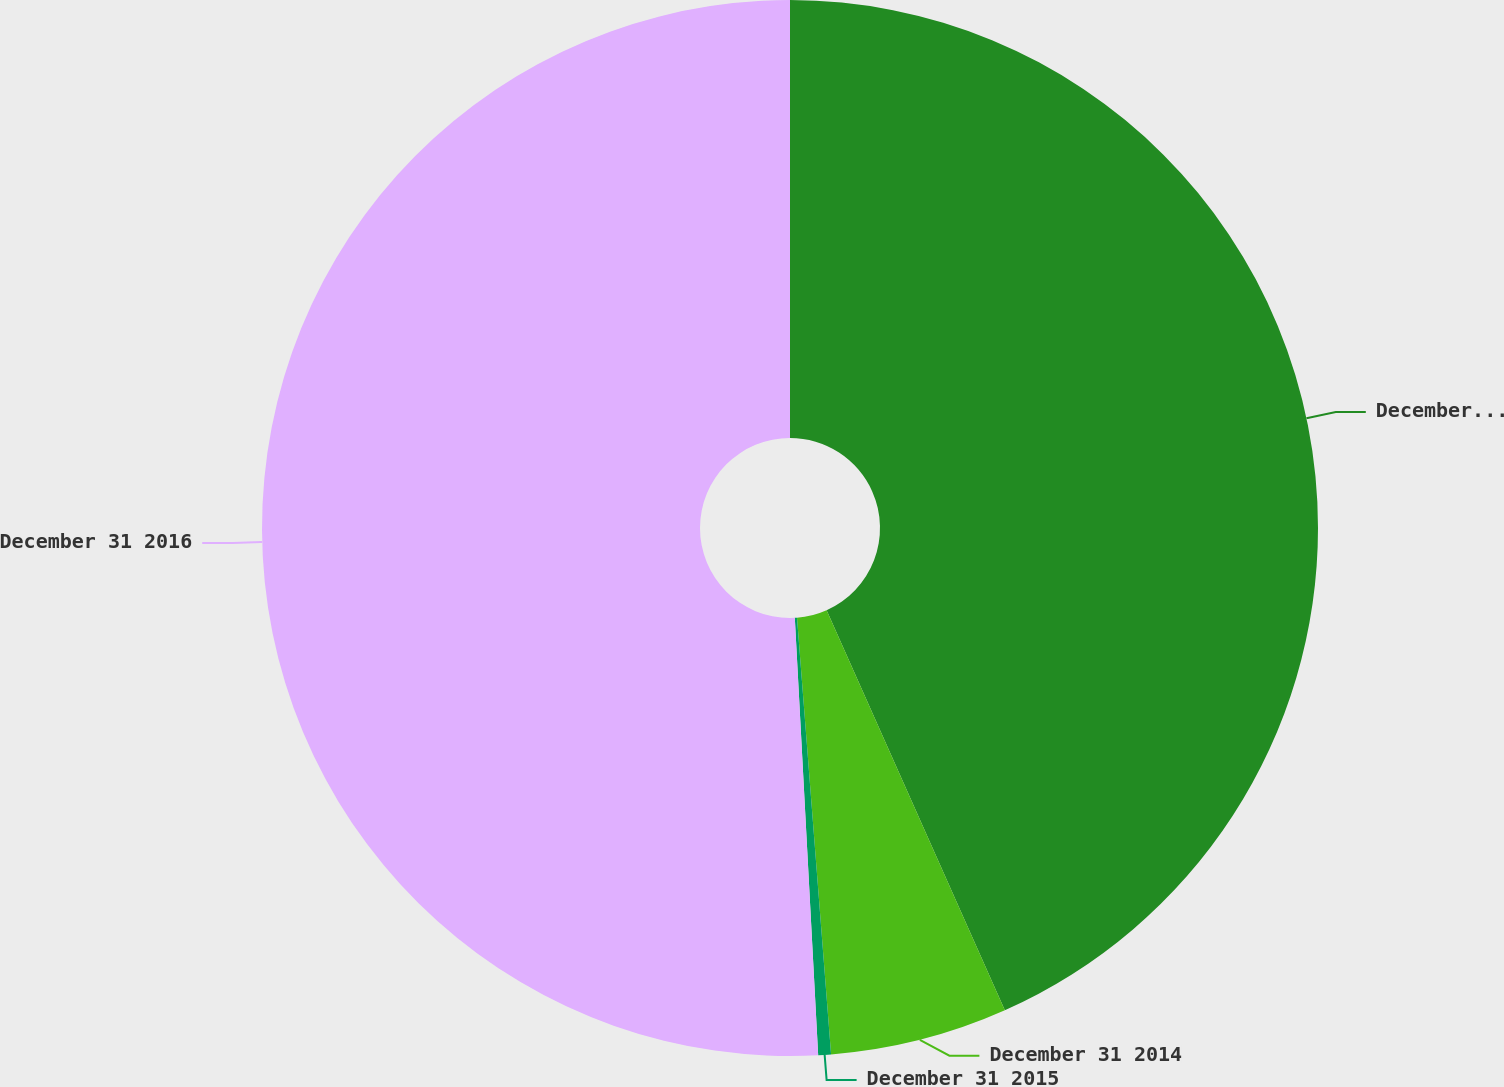Convert chart. <chart><loc_0><loc_0><loc_500><loc_500><pie_chart><fcel>December 31 2013<fcel>December 31 2014<fcel>December 31 2015<fcel>December 31 2016<nl><fcel>43.33%<fcel>5.43%<fcel>0.39%<fcel>50.85%<nl></chart> 